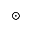Convert formula to latex. <formula><loc_0><loc_0><loc_500><loc_500>\odot</formula> 